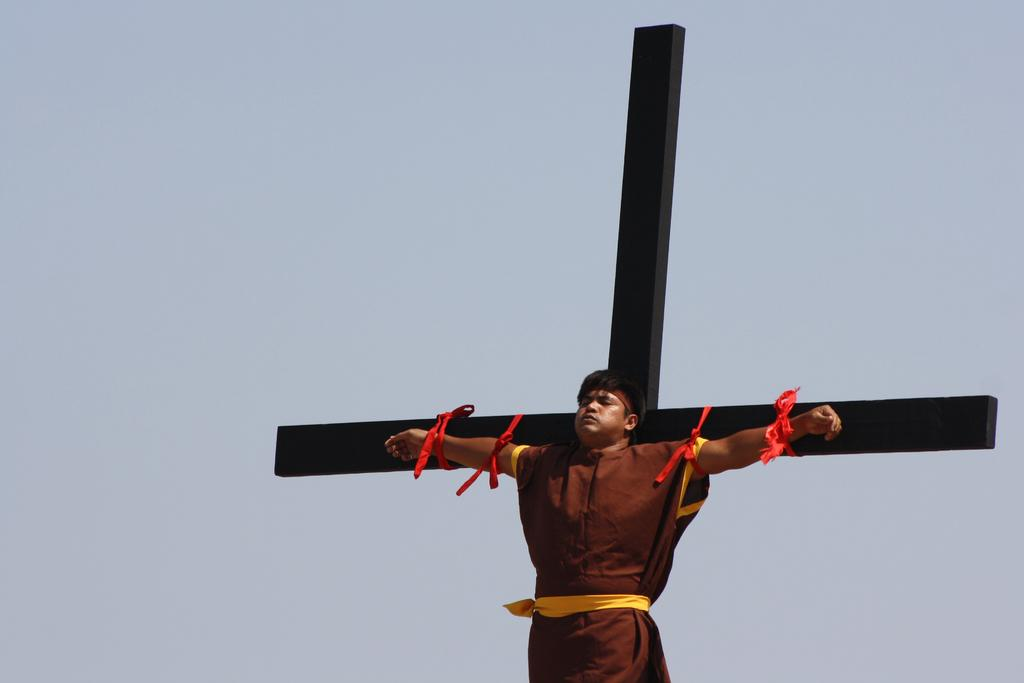What is the main subject of the image? There is a person hanging on the cross in the image. What can be seen in the background of the image? The sky is visible behind the cross. What type of discussion is taking place between the person and the cross in the image? There is no discussion taking place between the person and the cross in the image. The image only shows a person hanging on the cross with the sky visible in the background. 